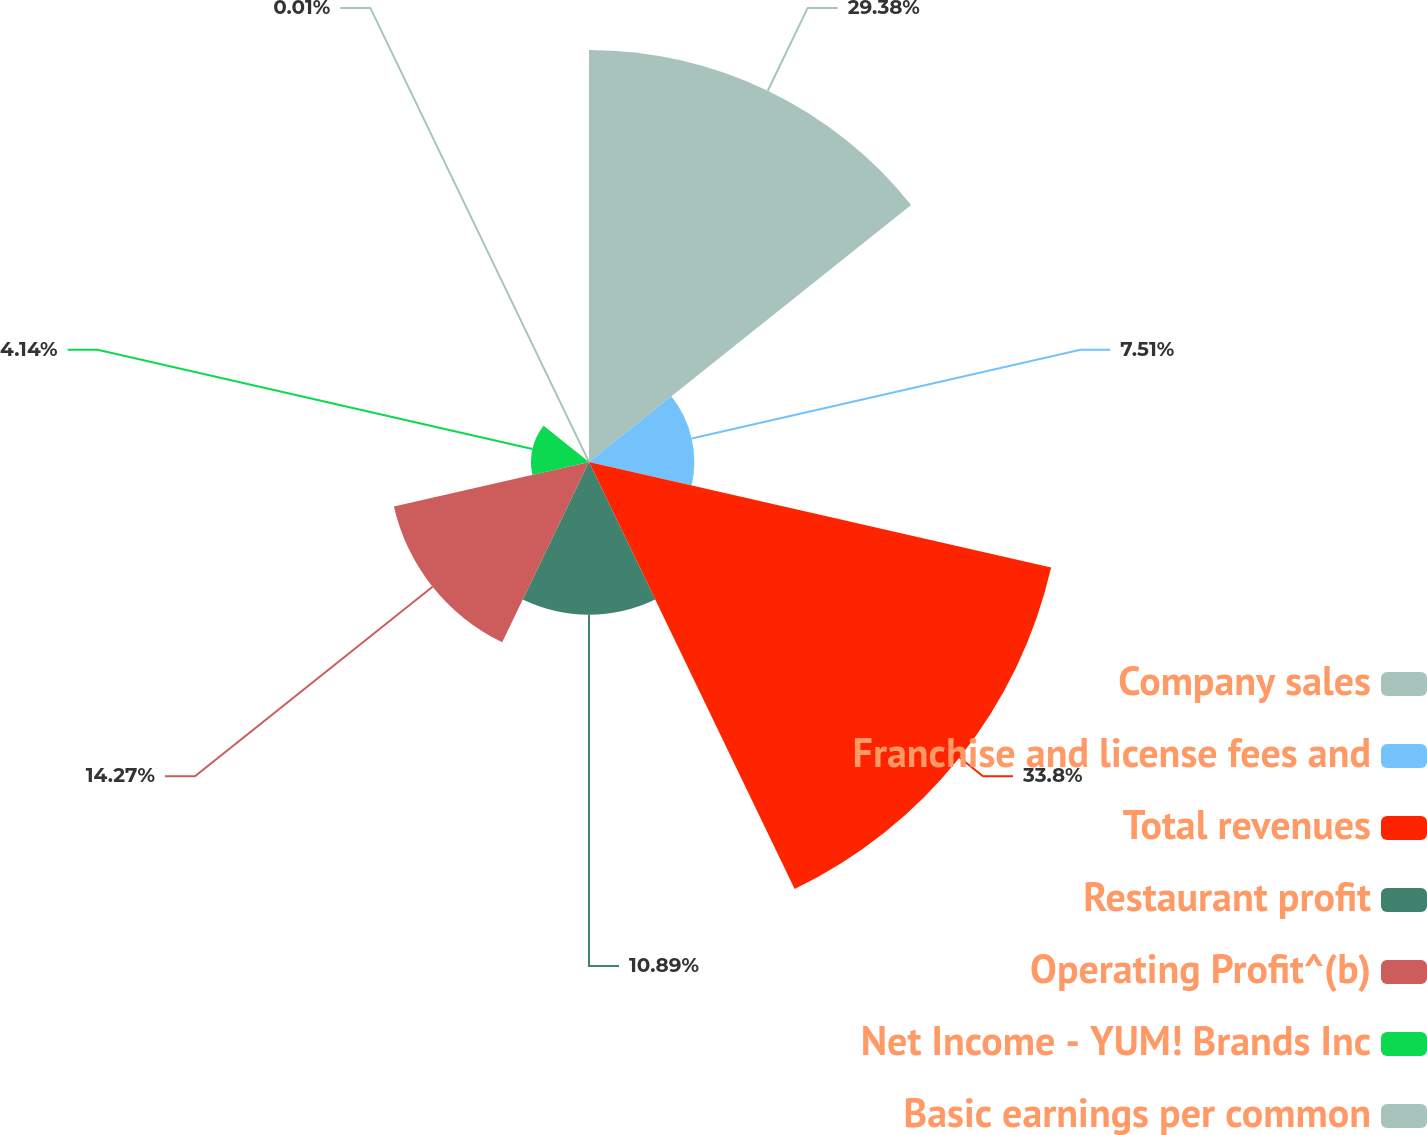<chart> <loc_0><loc_0><loc_500><loc_500><pie_chart><fcel>Company sales<fcel>Franchise and license fees and<fcel>Total revenues<fcel>Restaurant profit<fcel>Operating Profit^(b)<fcel>Net Income - YUM! Brands Inc<fcel>Basic earnings per common<nl><fcel>29.38%<fcel>7.51%<fcel>33.8%<fcel>10.89%<fcel>14.27%<fcel>4.14%<fcel>0.01%<nl></chart> 